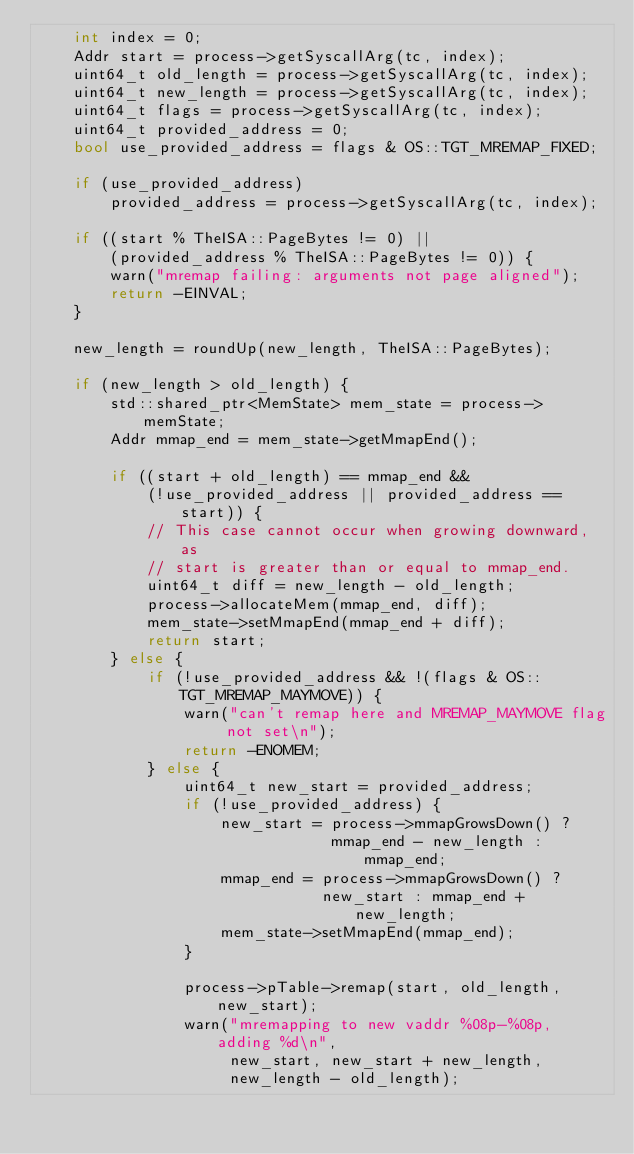<code> <loc_0><loc_0><loc_500><loc_500><_C++_>    int index = 0;
    Addr start = process->getSyscallArg(tc, index);
    uint64_t old_length = process->getSyscallArg(tc, index);
    uint64_t new_length = process->getSyscallArg(tc, index);
    uint64_t flags = process->getSyscallArg(tc, index);
    uint64_t provided_address = 0;
    bool use_provided_address = flags & OS::TGT_MREMAP_FIXED;

    if (use_provided_address)
        provided_address = process->getSyscallArg(tc, index);

    if ((start % TheISA::PageBytes != 0) ||
        (provided_address % TheISA::PageBytes != 0)) {
        warn("mremap failing: arguments not page aligned");
        return -EINVAL;
    }

    new_length = roundUp(new_length, TheISA::PageBytes);

    if (new_length > old_length) {
        std::shared_ptr<MemState> mem_state = process->memState;
        Addr mmap_end = mem_state->getMmapEnd();

        if ((start + old_length) == mmap_end &&
            (!use_provided_address || provided_address == start)) {
            // This case cannot occur when growing downward, as
            // start is greater than or equal to mmap_end.
            uint64_t diff = new_length - old_length;
            process->allocateMem(mmap_end, diff);
            mem_state->setMmapEnd(mmap_end + diff);
            return start;
        } else {
            if (!use_provided_address && !(flags & OS::TGT_MREMAP_MAYMOVE)) {
                warn("can't remap here and MREMAP_MAYMOVE flag not set\n");
                return -ENOMEM;
            } else {
                uint64_t new_start = provided_address;
                if (!use_provided_address) {
                    new_start = process->mmapGrowsDown() ?
                                mmap_end - new_length : mmap_end;
                    mmap_end = process->mmapGrowsDown() ?
                               new_start : mmap_end + new_length;
                    mem_state->setMmapEnd(mmap_end);
                }

                process->pTable->remap(start, old_length, new_start);
                warn("mremapping to new vaddr %08p-%08p, adding %d\n",
                     new_start, new_start + new_length,
                     new_length - old_length);</code> 